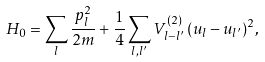<formula> <loc_0><loc_0><loc_500><loc_500>H _ { 0 } = \sum _ { l } \frac { p _ { l } ^ { 2 } } { 2 m } + \frac { 1 } { 4 } \sum _ { l , l ^ { \prime } } V _ { l - l ^ { \prime } } ^ { ( 2 ) } \, ( u _ { l } - u _ { l ^ { \prime } } ) ^ { 2 } ,</formula> 